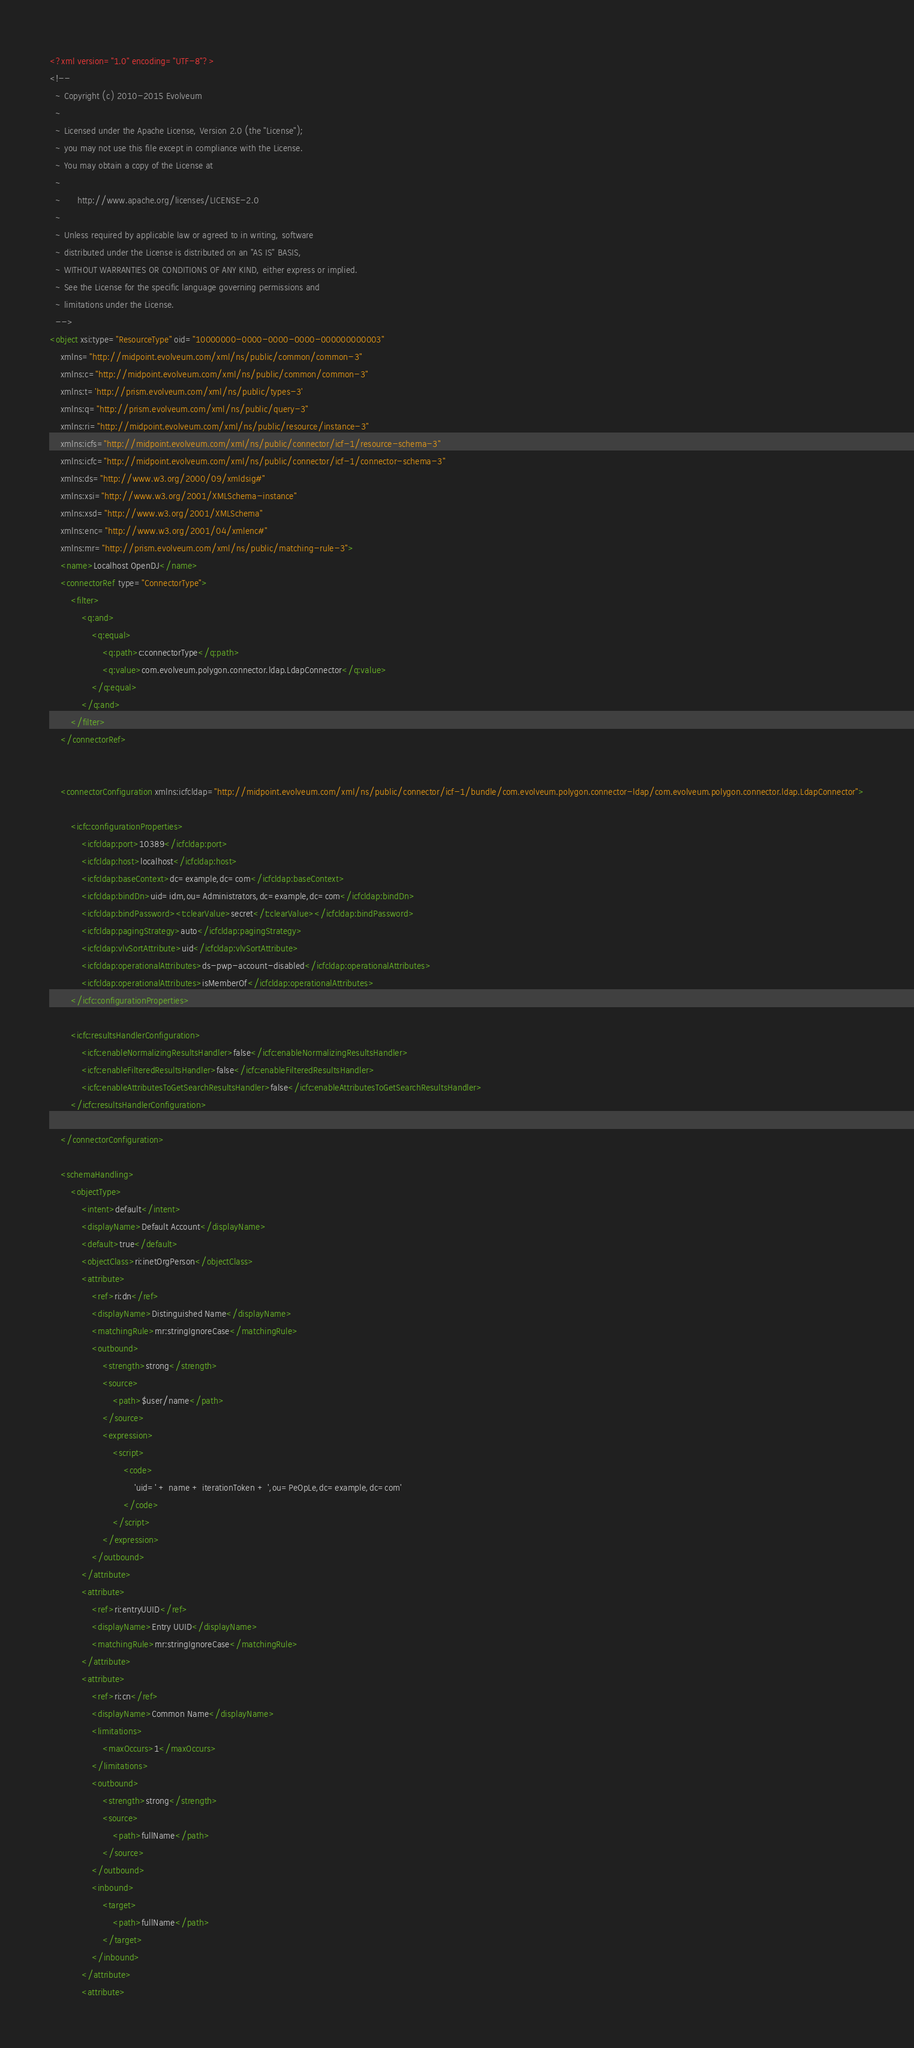Convert code to text. <code><loc_0><loc_0><loc_500><loc_500><_XML_><?xml version="1.0" encoding="UTF-8"?>
<!--
  ~ Copyright (c) 2010-2015 Evolveum
  ~
  ~ Licensed under the Apache License, Version 2.0 (the "License");
  ~ you may not use this file except in compliance with the License.
  ~ You may obtain a copy of the License at
  ~
  ~      http://www.apache.org/licenses/LICENSE-2.0
  ~
  ~ Unless required by applicable law or agreed to in writing, software
  ~ distributed under the License is distributed on an "AS IS" BASIS,
  ~ WITHOUT WARRANTIES OR CONDITIONS OF ANY KIND, either express or implied.
  ~ See the License for the specific language governing permissions and
  ~ limitations under the License.
  -->
<object xsi:type="ResourceType" oid="10000000-0000-0000-0000-000000000003" 
	xmlns="http://midpoint.evolveum.com/xml/ns/public/common/common-3"
	xmlns:c="http://midpoint.evolveum.com/xml/ns/public/common/common-3"
	xmlns:t='http://prism.evolveum.com/xml/ns/public/types-3'
	xmlns:q="http://prism.evolveum.com/xml/ns/public/query-3"
	xmlns:ri="http://midpoint.evolveum.com/xml/ns/public/resource/instance-3"
	xmlns:icfs="http://midpoint.evolveum.com/xml/ns/public/connector/icf-1/resource-schema-3"
	xmlns:icfc="http://midpoint.evolveum.com/xml/ns/public/connector/icf-1/connector-schema-3"
	xmlns:ds="http://www.w3.org/2000/09/xmldsig#"
	xmlns:xsi="http://www.w3.org/2001/XMLSchema-instance"
	xmlns:xsd="http://www.w3.org/2001/XMLSchema"
	xmlns:enc="http://www.w3.org/2001/04/xmlenc#"
	xmlns:mr="http://prism.evolveum.com/xml/ns/public/matching-rule-3">
	<name>Localhost OpenDJ</name>
	<connectorRef type="ConnectorType">
	    <filter>
			<q:and>
				<q:equal>
					<q:path>c:connectorType</q:path>
					<q:value>com.evolveum.polygon.connector.ldap.LdapConnector</q:value>
				</q:equal>
			</q:and>
		</filter>
	</connectorRef>
	
	
	<connectorConfiguration xmlns:icfcldap="http://midpoint.evolveum.com/xml/ns/public/connector/icf-1/bundle/com.evolveum.polygon.connector-ldap/com.evolveum.polygon.connector.ldap.LdapConnector">
					   
		<icfc:configurationProperties>
			<icfcldap:port>10389</icfcldap:port>
			<icfcldap:host>localhost</icfcldap:host>
			<icfcldap:baseContext>dc=example,dc=com</icfcldap:baseContext>
			<icfcldap:bindDn>uid=idm,ou=Administrators,dc=example,dc=com</icfcldap:bindDn>
			<icfcldap:bindPassword><t:clearValue>secret</t:clearValue></icfcldap:bindPassword>
			<icfcldap:pagingStrategy>auto</icfcldap:pagingStrategy>
			<icfcldap:vlvSortAttribute>uid</icfcldap:vlvSortAttribute>
 			<icfcldap:operationalAttributes>ds-pwp-account-disabled</icfcldap:operationalAttributes>
 			<icfcldap:operationalAttributes>isMemberOf</icfcldap:operationalAttributes>
		</icfc:configurationProperties>
		
		<icfc:resultsHandlerConfiguration>
			<icfc:enableNormalizingResultsHandler>false</icfc:enableNormalizingResultsHandler>
			<icfc:enableFilteredResultsHandler>false</icfc:enableFilteredResultsHandler>
			<icfc:enableAttributesToGetSearchResultsHandler>false</icfc:enableAttributesToGetSearchResultsHandler>
		</icfc:resultsHandlerConfiguration>
	
	</connectorConfiguration>
		
	<schemaHandling>
		<objectType>
			<intent>default</intent>
			<displayName>Default Account</displayName>
			<default>true</default>
			<objectClass>ri:inetOrgPerson</objectClass>
			<attribute>
				<ref>ri:dn</ref>
				<displayName>Distinguished Name</displayName>
				<matchingRule>mr:stringIgnoreCase</matchingRule>
				<outbound>
					<strength>strong</strength>
				    <source>
				    	<path>$user/name</path>
				    </source>
					<expression>
						<script>
							<code>
								'uid=' + name + iterationToken + ',ou=PeOpLe,dc=example,dc=com'
							</code>
						</script>
					</expression>
				</outbound>
			</attribute>
			<attribute>
				<ref>ri:entryUUID</ref>
				<displayName>Entry UUID</displayName>
				<matchingRule>mr:stringIgnoreCase</matchingRule>
			</attribute>
			<attribute>
				<ref>ri:cn</ref>
				<displayName>Common Name</displayName>
				<limitations>
					<maxOccurs>1</maxOccurs>
				</limitations>
				<outbound>
					<strength>strong</strength>
					<source>
						<path>fullName</path>
					</source>
				</outbound>
				<inbound>
					<target>
						<path>fullName</path>
					</target>
				</inbound>
			</attribute>
			<attribute></code> 